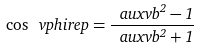<formula> <loc_0><loc_0><loc_500><loc_500>\cos \ v p h i r e p = \frac { \ a u x v b ^ { 2 } - 1 } { \ a u x v b ^ { 2 } + 1 }</formula> 